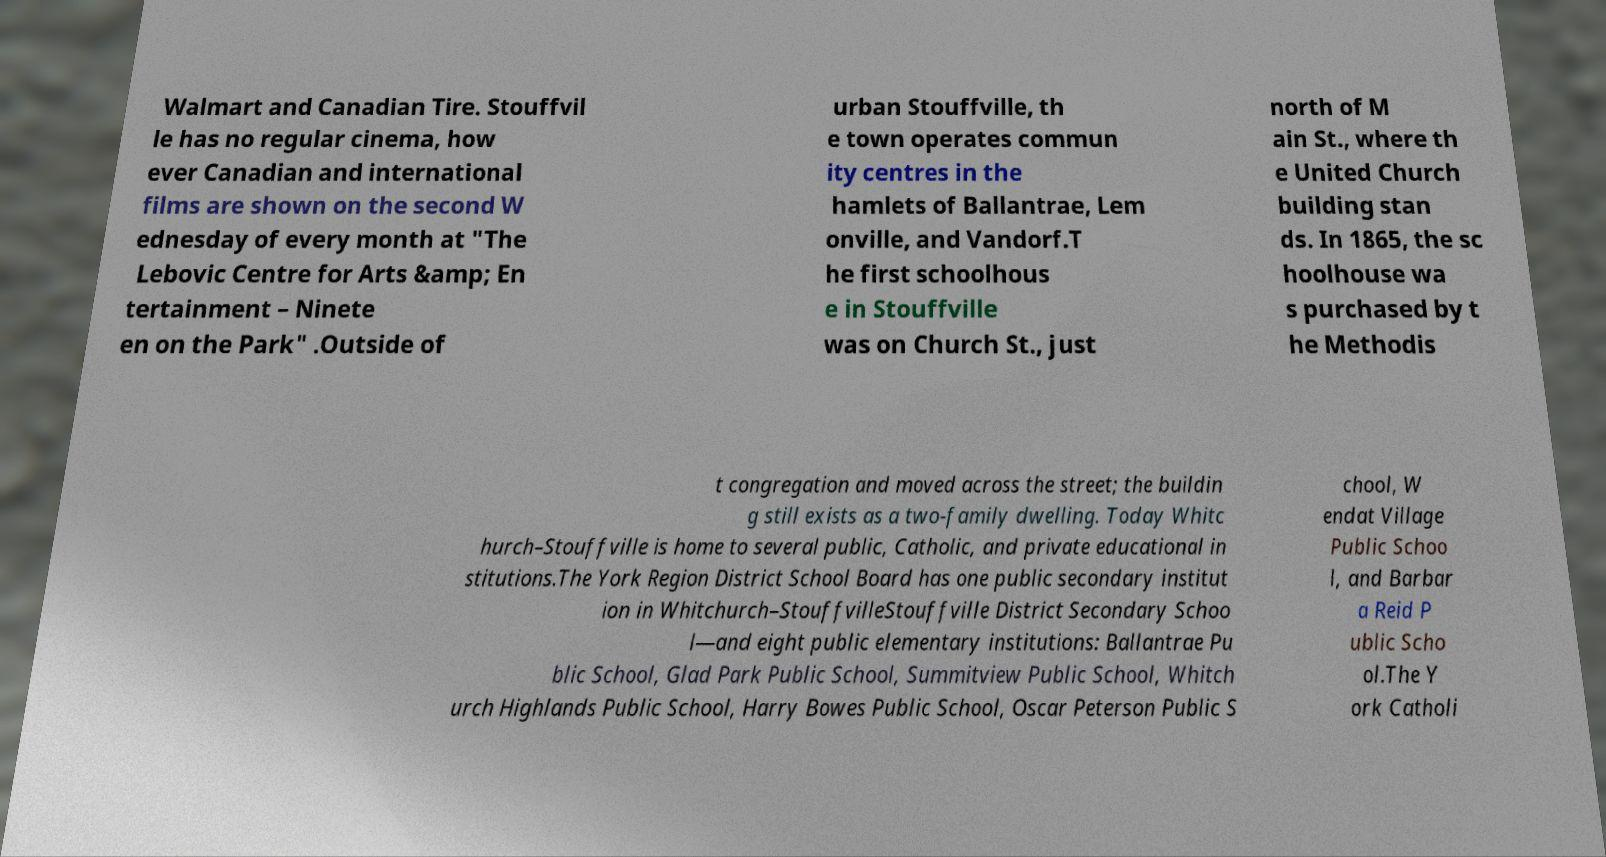Can you accurately transcribe the text from the provided image for me? Walmart and Canadian Tire. Stouffvil le has no regular cinema, how ever Canadian and international films are shown on the second W ednesday of every month at "The Lebovic Centre for Arts &amp; En tertainment – Ninete en on the Park" .Outside of urban Stouffville, th e town operates commun ity centres in the hamlets of Ballantrae, Lem onville, and Vandorf.T he first schoolhous e in Stouffville was on Church St., just north of M ain St., where th e United Church building stan ds. In 1865, the sc hoolhouse wa s purchased by t he Methodis t congregation and moved across the street; the buildin g still exists as a two-family dwelling. Today Whitc hurch–Stouffville is home to several public, Catholic, and private educational in stitutions.The York Region District School Board has one public secondary institut ion in Whitchurch–StouffvilleStouffville District Secondary Schoo l—and eight public elementary institutions: Ballantrae Pu blic School, Glad Park Public School, Summitview Public School, Whitch urch Highlands Public School, Harry Bowes Public School, Oscar Peterson Public S chool, W endat Village Public Schoo l, and Barbar a Reid P ublic Scho ol.The Y ork Catholi 